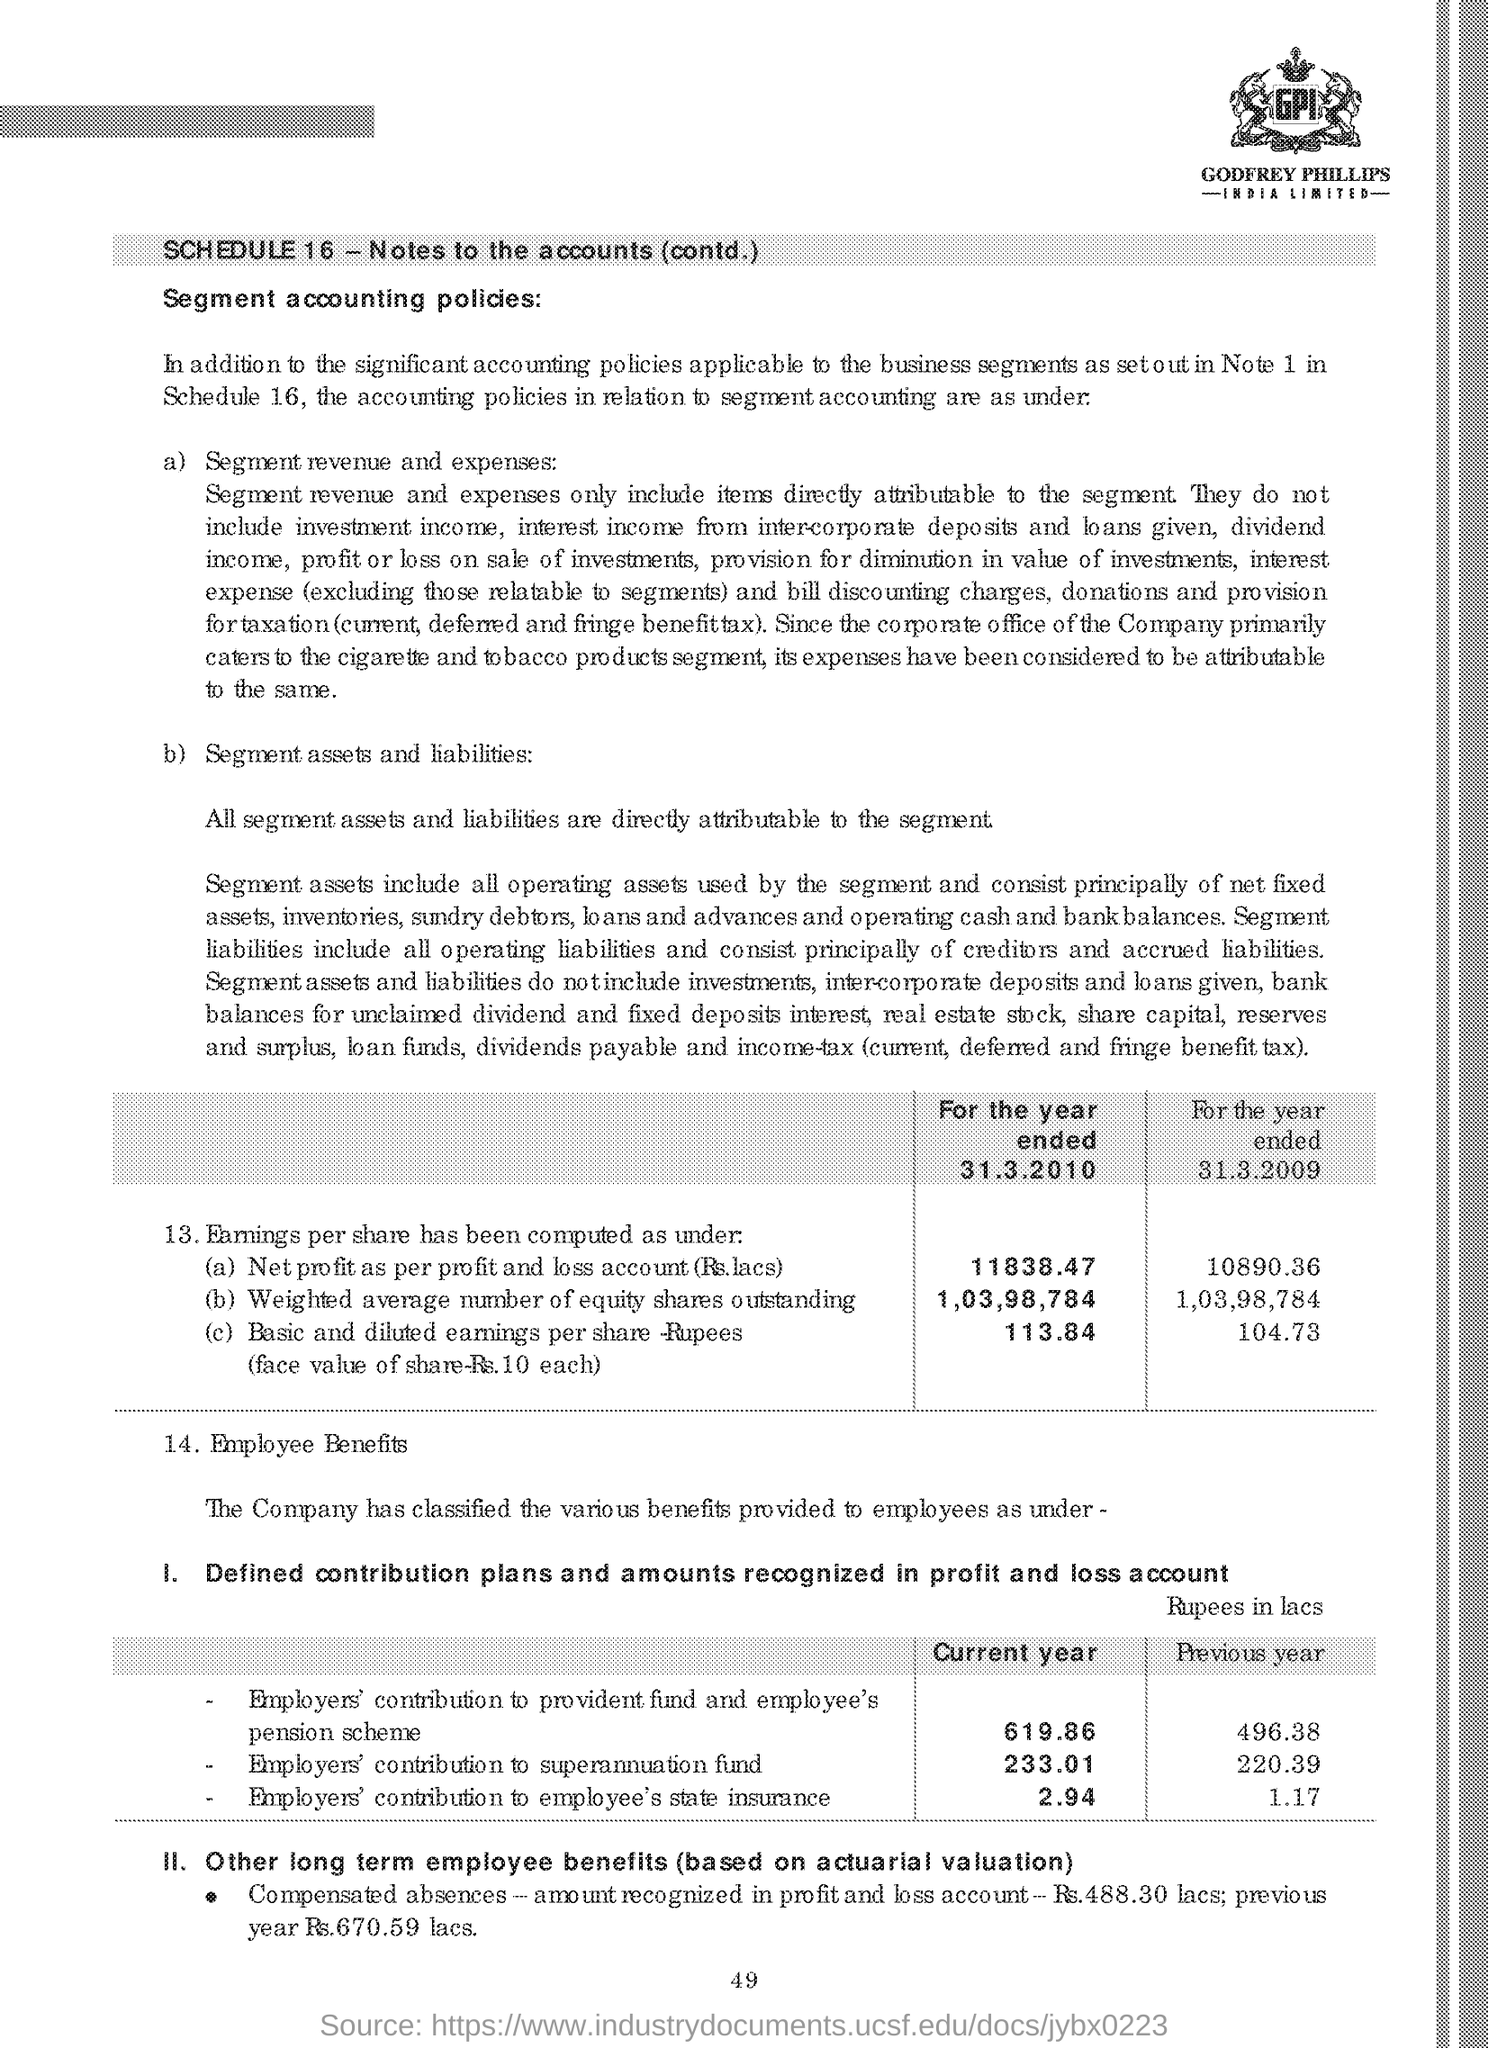Give some essential details in this illustration. The employers' contribution to the provident fund and employee's pension scheme in the current year is 619.86 lakhs. The employer's contribution to the superannuation fund in the current year is 233.01 lakhs. The net profit for the year ended March 31, 2010, as per the profit and loss account, was 11,838.47 lakhs. The employer's contribution to the Employee State Insurance in the previous year was 1.17 crores. The page number mentioned in this document is 49. 